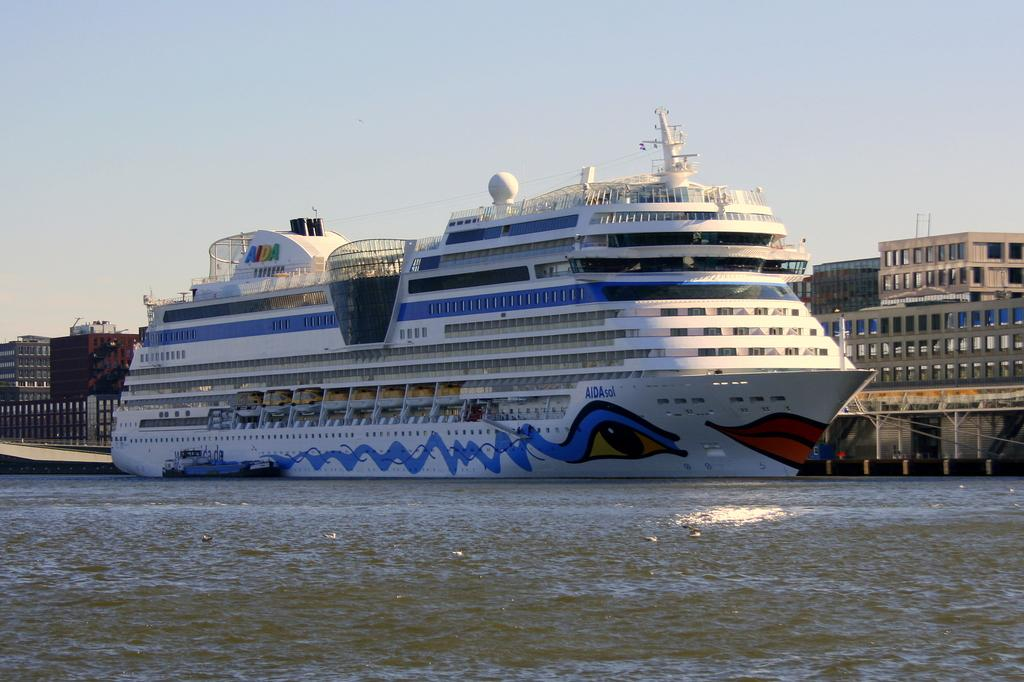What is the main subject of the image? There is a ship visible in the lake. What can be seen in the background of the image? The sky and a building are visible in the background of the image. What type of calendar is hanging on the wall of the ship? There is no calendar visible in the image, as the focus is on the ship in the lake and the background elements. 